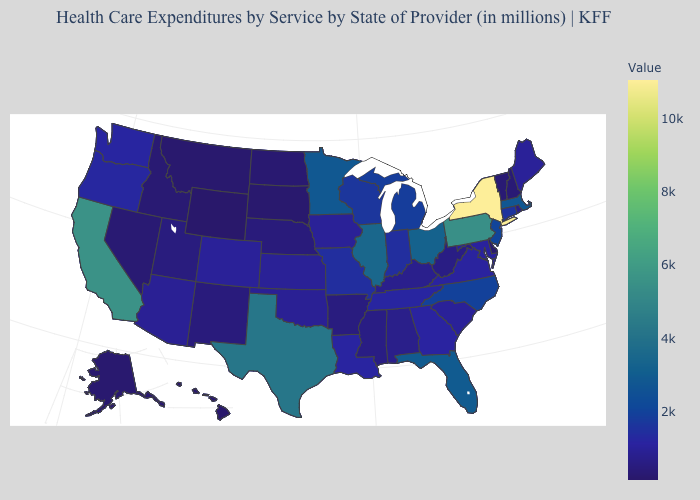Which states have the lowest value in the USA?
Keep it brief. Wyoming. Does South Dakota have the lowest value in the MidWest?
Write a very short answer. Yes. Which states have the lowest value in the USA?
Keep it brief. Wyoming. Is the legend a continuous bar?
Short answer required. Yes. Does Louisiana have the lowest value in the USA?
Be succinct. No. Which states have the lowest value in the South?
Write a very short answer. Delaware. 